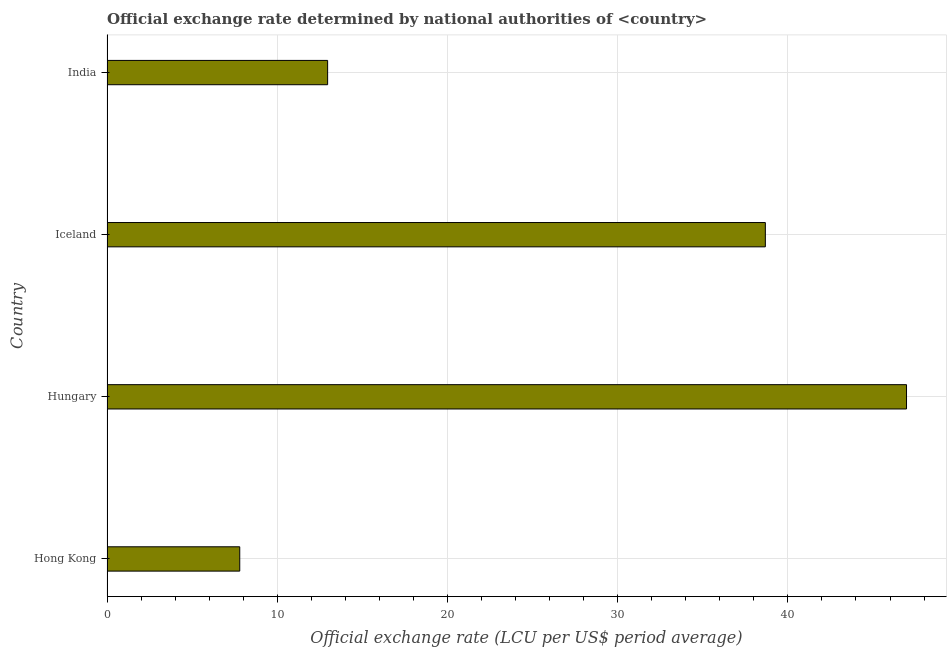Does the graph contain grids?
Offer a very short reply. Yes. What is the title of the graph?
Offer a terse response. Official exchange rate determined by national authorities of <country>. What is the label or title of the X-axis?
Offer a very short reply. Official exchange rate (LCU per US$ period average). What is the official exchange rate in Hong Kong?
Ensure brevity in your answer.  7.8. Across all countries, what is the maximum official exchange rate?
Your answer should be very brief. 46.97. Across all countries, what is the minimum official exchange rate?
Offer a very short reply. 7.8. In which country was the official exchange rate maximum?
Give a very brief answer. Hungary. In which country was the official exchange rate minimum?
Provide a succinct answer. Hong Kong. What is the sum of the official exchange rate?
Offer a terse response. 106.41. What is the difference between the official exchange rate in Hungary and Iceland?
Keep it short and to the point. 8.29. What is the average official exchange rate per country?
Keep it short and to the point. 26.6. What is the median official exchange rate?
Provide a succinct answer. 25.82. In how many countries, is the official exchange rate greater than 36 ?
Make the answer very short. 2. What is the ratio of the official exchange rate in Hong Kong to that in Hungary?
Ensure brevity in your answer.  0.17. Is the official exchange rate in Hong Kong less than that in India?
Ensure brevity in your answer.  Yes. What is the difference between the highest and the second highest official exchange rate?
Provide a short and direct response. 8.29. Is the sum of the official exchange rate in Hungary and Iceland greater than the maximum official exchange rate across all countries?
Offer a terse response. Yes. What is the difference between the highest and the lowest official exchange rate?
Your response must be concise. 39.17. How many bars are there?
Provide a succinct answer. 4. Are all the bars in the graph horizontal?
Give a very brief answer. Yes. What is the difference between two consecutive major ticks on the X-axis?
Offer a terse response. 10. Are the values on the major ticks of X-axis written in scientific E-notation?
Your response must be concise. No. What is the Official exchange rate (LCU per US$ period average) of Hong Kong?
Give a very brief answer. 7.8. What is the Official exchange rate (LCU per US$ period average) of Hungary?
Your response must be concise. 46.97. What is the Official exchange rate (LCU per US$ period average) of Iceland?
Ensure brevity in your answer.  38.68. What is the Official exchange rate (LCU per US$ period average) in India?
Offer a very short reply. 12.96. What is the difference between the Official exchange rate (LCU per US$ period average) in Hong Kong and Hungary?
Offer a very short reply. -39.17. What is the difference between the Official exchange rate (LCU per US$ period average) in Hong Kong and Iceland?
Keep it short and to the point. -30.88. What is the difference between the Official exchange rate (LCU per US$ period average) in Hong Kong and India?
Your response must be concise. -5.16. What is the difference between the Official exchange rate (LCU per US$ period average) in Hungary and Iceland?
Your answer should be compact. 8.29. What is the difference between the Official exchange rate (LCU per US$ period average) in Hungary and India?
Offer a very short reply. 34.01. What is the difference between the Official exchange rate (LCU per US$ period average) in Iceland and India?
Provide a short and direct response. 25.72. What is the ratio of the Official exchange rate (LCU per US$ period average) in Hong Kong to that in Hungary?
Give a very brief answer. 0.17. What is the ratio of the Official exchange rate (LCU per US$ period average) in Hong Kong to that in Iceland?
Your answer should be very brief. 0.2. What is the ratio of the Official exchange rate (LCU per US$ period average) in Hong Kong to that in India?
Keep it short and to the point. 0.6. What is the ratio of the Official exchange rate (LCU per US$ period average) in Hungary to that in Iceland?
Offer a very short reply. 1.21. What is the ratio of the Official exchange rate (LCU per US$ period average) in Hungary to that in India?
Your answer should be very brief. 3.62. What is the ratio of the Official exchange rate (LCU per US$ period average) in Iceland to that in India?
Provide a succinct answer. 2.98. 